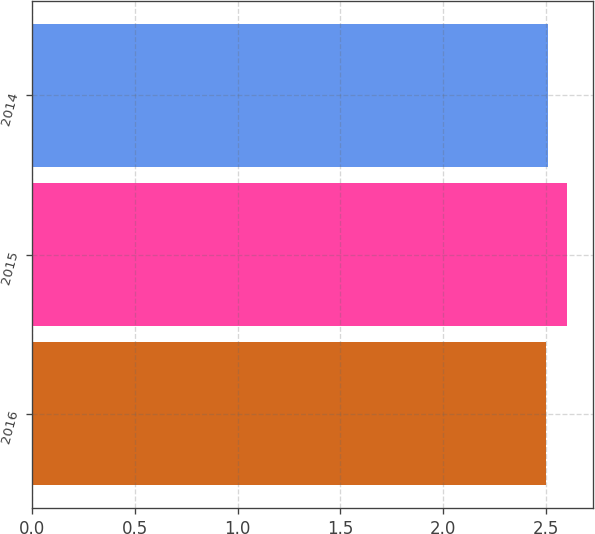<chart> <loc_0><loc_0><loc_500><loc_500><bar_chart><fcel>2016<fcel>2015<fcel>2014<nl><fcel>2.5<fcel>2.6<fcel>2.51<nl></chart> 